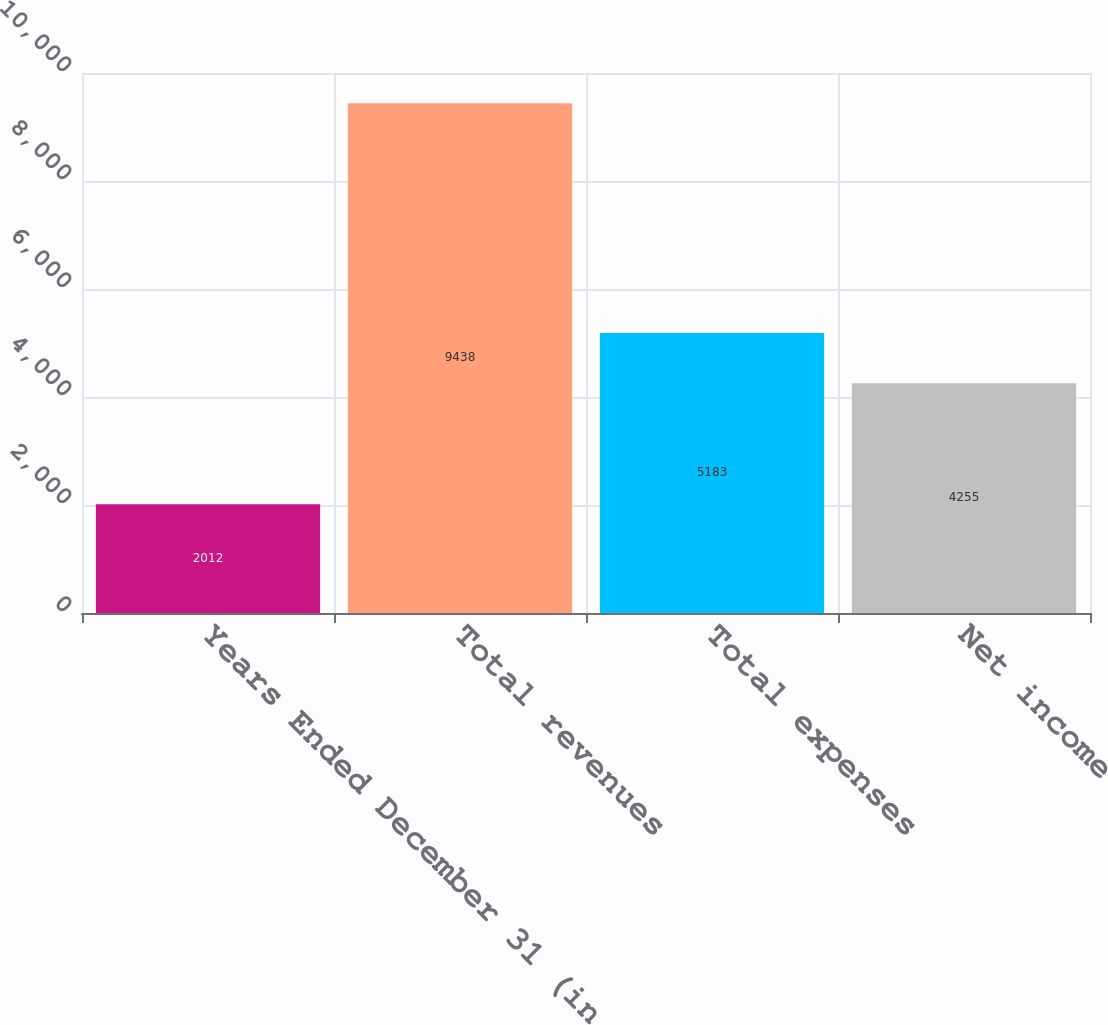Convert chart to OTSL. <chart><loc_0><loc_0><loc_500><loc_500><bar_chart><fcel>Years Ended December 31 (in<fcel>Total revenues<fcel>Total expenses<fcel>Net income<nl><fcel>2012<fcel>9438<fcel>5183<fcel>4255<nl></chart> 